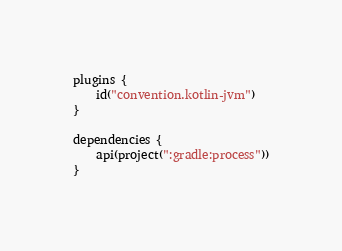<code> <loc_0><loc_0><loc_500><loc_500><_Kotlin_>plugins {
    id("convention.kotlin-jvm")
}

dependencies {
    api(project(":gradle:process"))
}
</code> 